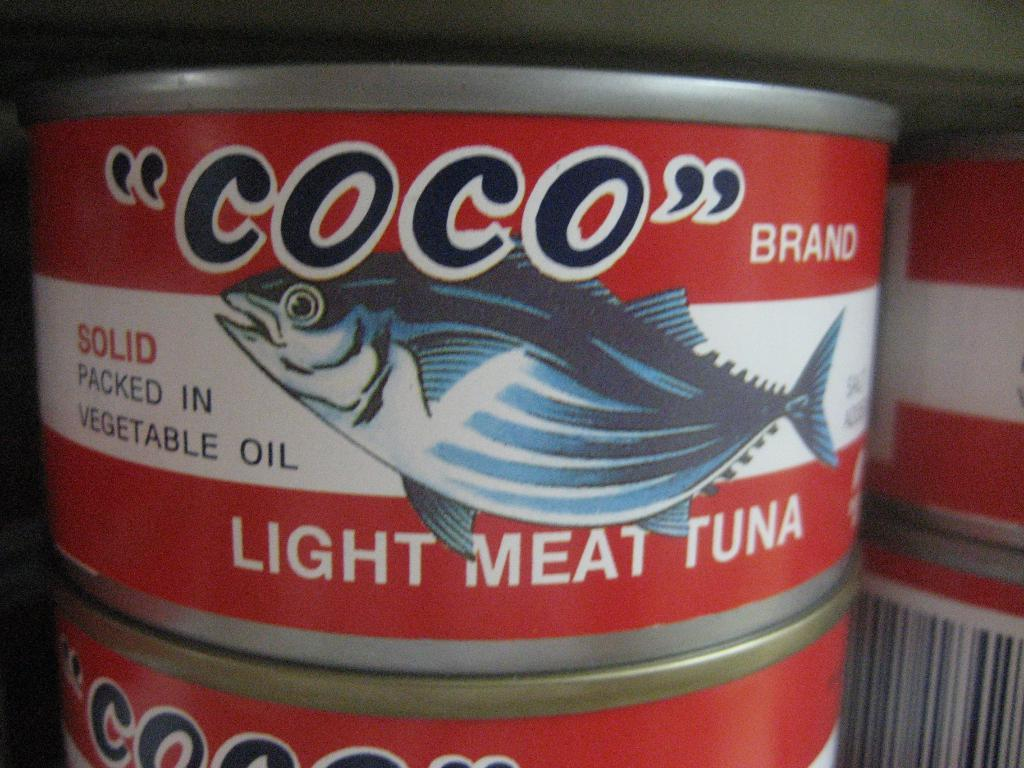<image>
Describe the image concisely. A can of Coco tuna packed in vegetable oil. 